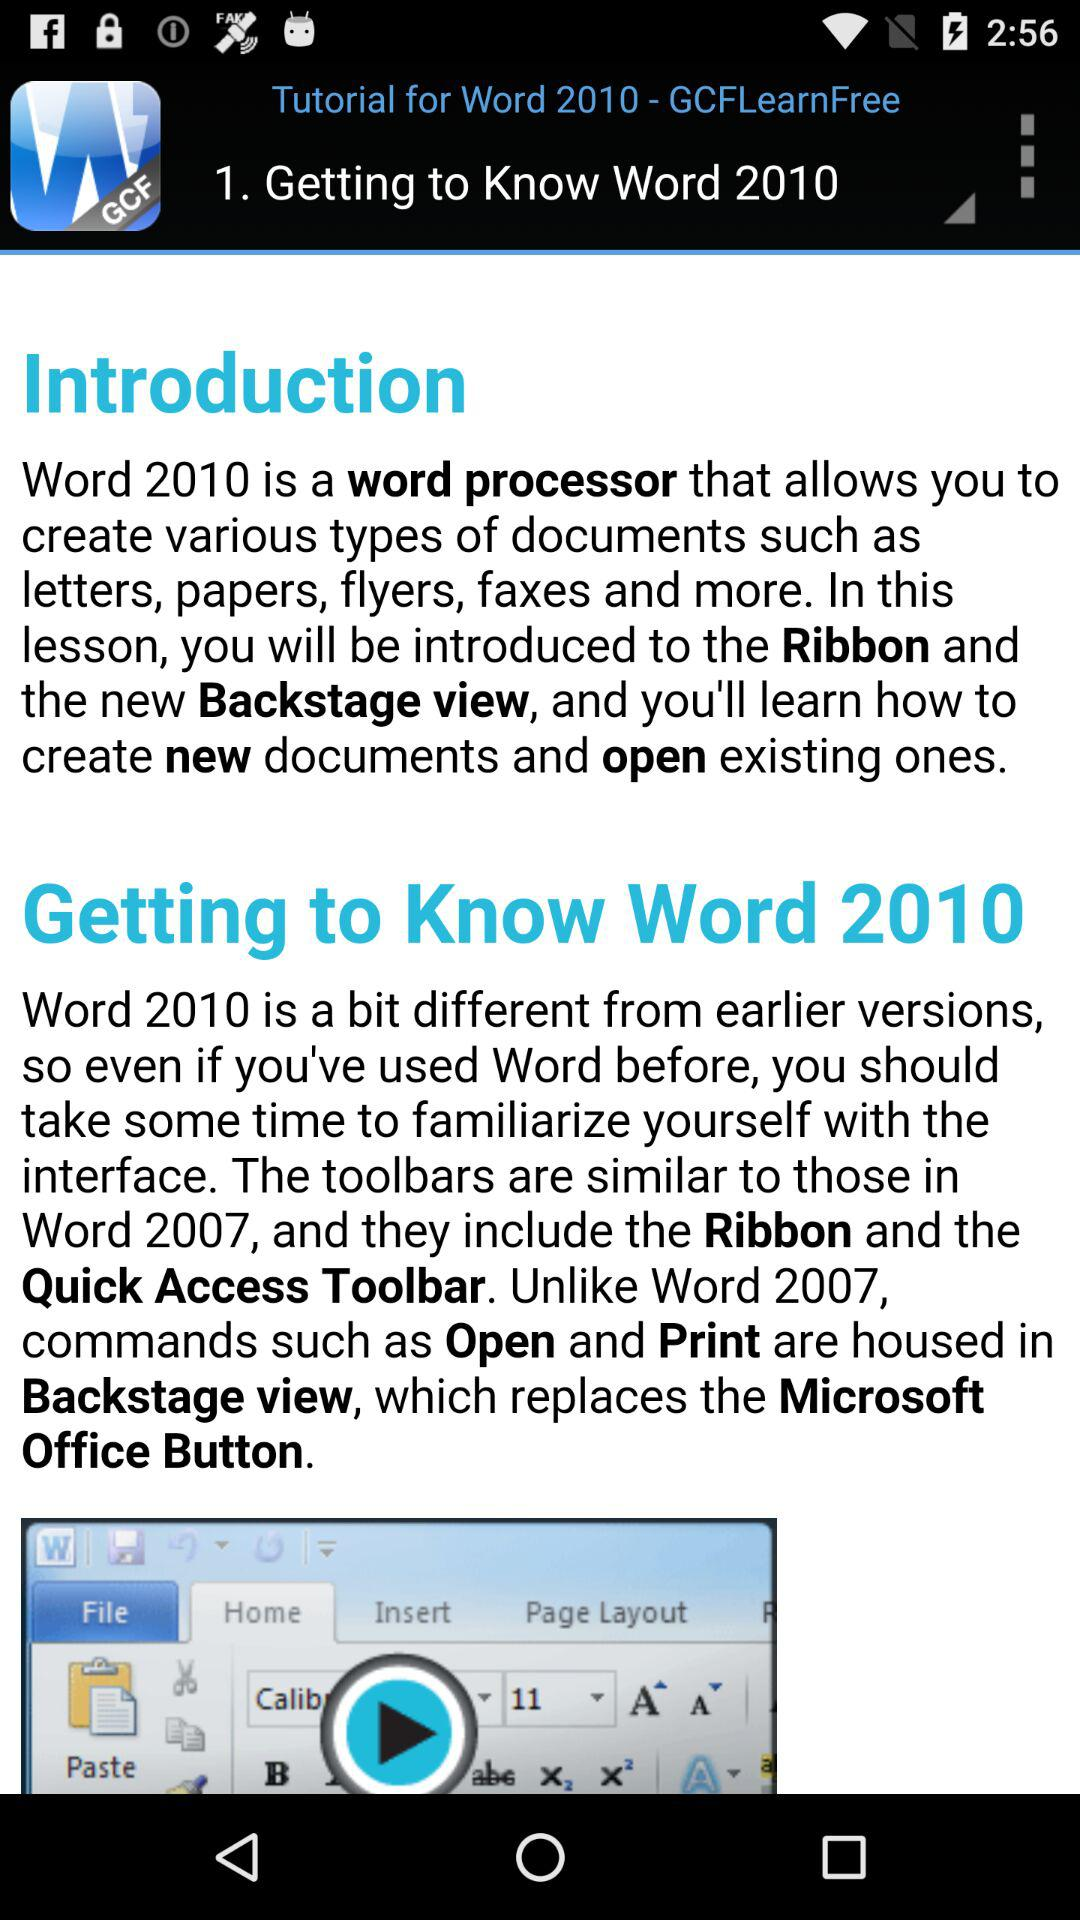What is the name of the application?
When the provided information is insufficient, respond with <no answer>. <no answer> 